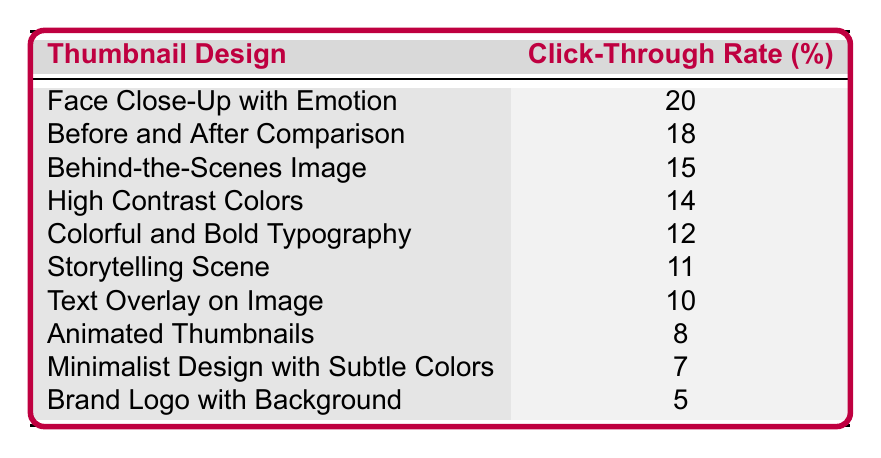What is the highest click-through rate in the table? The highest click-through rate shown in the table is 20%, which corresponds to the "Face Close-Up with Emotion" thumbnail design.
Answer: 20% Which thumbnail design has a click-through rate of 14%? The thumbnail design that has a click-through rate of 14% is "High Contrast Colors."
Answer: High Contrast Colors What is the average click-through rate of the thumbnails listed? To calculate the average, add all click-through rates together: 20 + 18 + 15 + 14 + 12 + 11 + 10 + 8 + 7 + 5 =  127. There are 10 thumbnails, so the average is 127/10 = 12.7%.
Answer: 12.7% Is the click-through rate for "Animated Thumbnails" greater than that for "Brand Logo with Background"? "Animated Thumbnails" has a click-through rate of 8%, while "Brand Logo with Background" has a click-through rate of 5%. Since 8% is greater than 5%, the statement is true.
Answer: Yes How many thumbnail designs have a click-through rate less than 10%? The designs with rates less than 10% are "Animated Thumbnails" (8%), "Minimalist Design with Subtle Colors" (7%), and "Brand Logo with Background" (5%). That's a total of 3 designs.
Answer: 3 Which two thumbnail designs have the highest click-through rates without being over 15%? The two designs with the highest click-through rates below 15% are "High Contrast Colors" at 14% and "Colorful and Bold Typography" at 12%. Adding them gives a pair that can be identified without exceeding 15%.
Answer: High Contrast Colors and Colorful and Bold Typography What is the difference between the click-through rates of "Before and After Comparison" and "Text Overlay on Image"? The click-through rate for "Before and After Comparison" is 18% and for "Text Overlay on Image" it is 10%. Calculating the difference: 18 - 10 = 8%.
Answer: 8% Which thumbnail design has the third highest click-through rate? The third highest click-through rate belongs to "Behind-the-Scenes Image," which has a rate of 15%. This can be identified by counting down the list from the top.
Answer: Behind-the-Scenes Image 